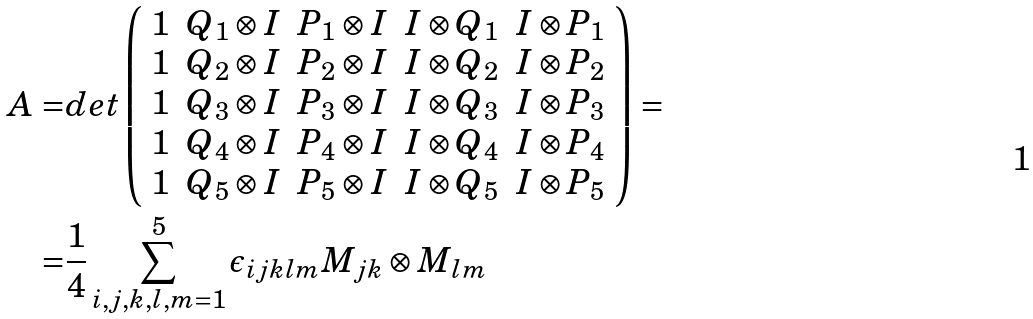Convert formula to latex. <formula><loc_0><loc_0><loc_500><loc_500>A = & d e t \left ( \begin{array} { c c c c c } 1 & Q _ { 1 } \otimes I & P _ { 1 } \otimes I & I \otimes Q _ { 1 } & I \otimes P _ { 1 } \\ 1 & Q _ { 2 } \otimes I & P _ { 2 } \otimes I & I \otimes Q _ { 2 } & I \otimes P _ { 2 } \\ 1 & Q _ { 3 } \otimes I & P _ { 3 } \otimes I & I \otimes Q _ { 3 } & I \otimes P _ { 3 } \\ 1 & Q _ { 4 } \otimes I & P _ { 4 } \otimes I & I \otimes Q _ { 4 } & I \otimes P _ { 4 } \\ 1 & Q _ { 5 } \otimes I & P _ { 5 } \otimes I & I \otimes Q _ { 5 } & I \otimes P _ { 5 } \end{array} \right ) = \\ = & \frac { 1 } { 4 } \sum _ { i , j , k , l , m = 1 } ^ { 5 } \epsilon _ { i j k l m } M _ { j k } \otimes M _ { l m }</formula> 